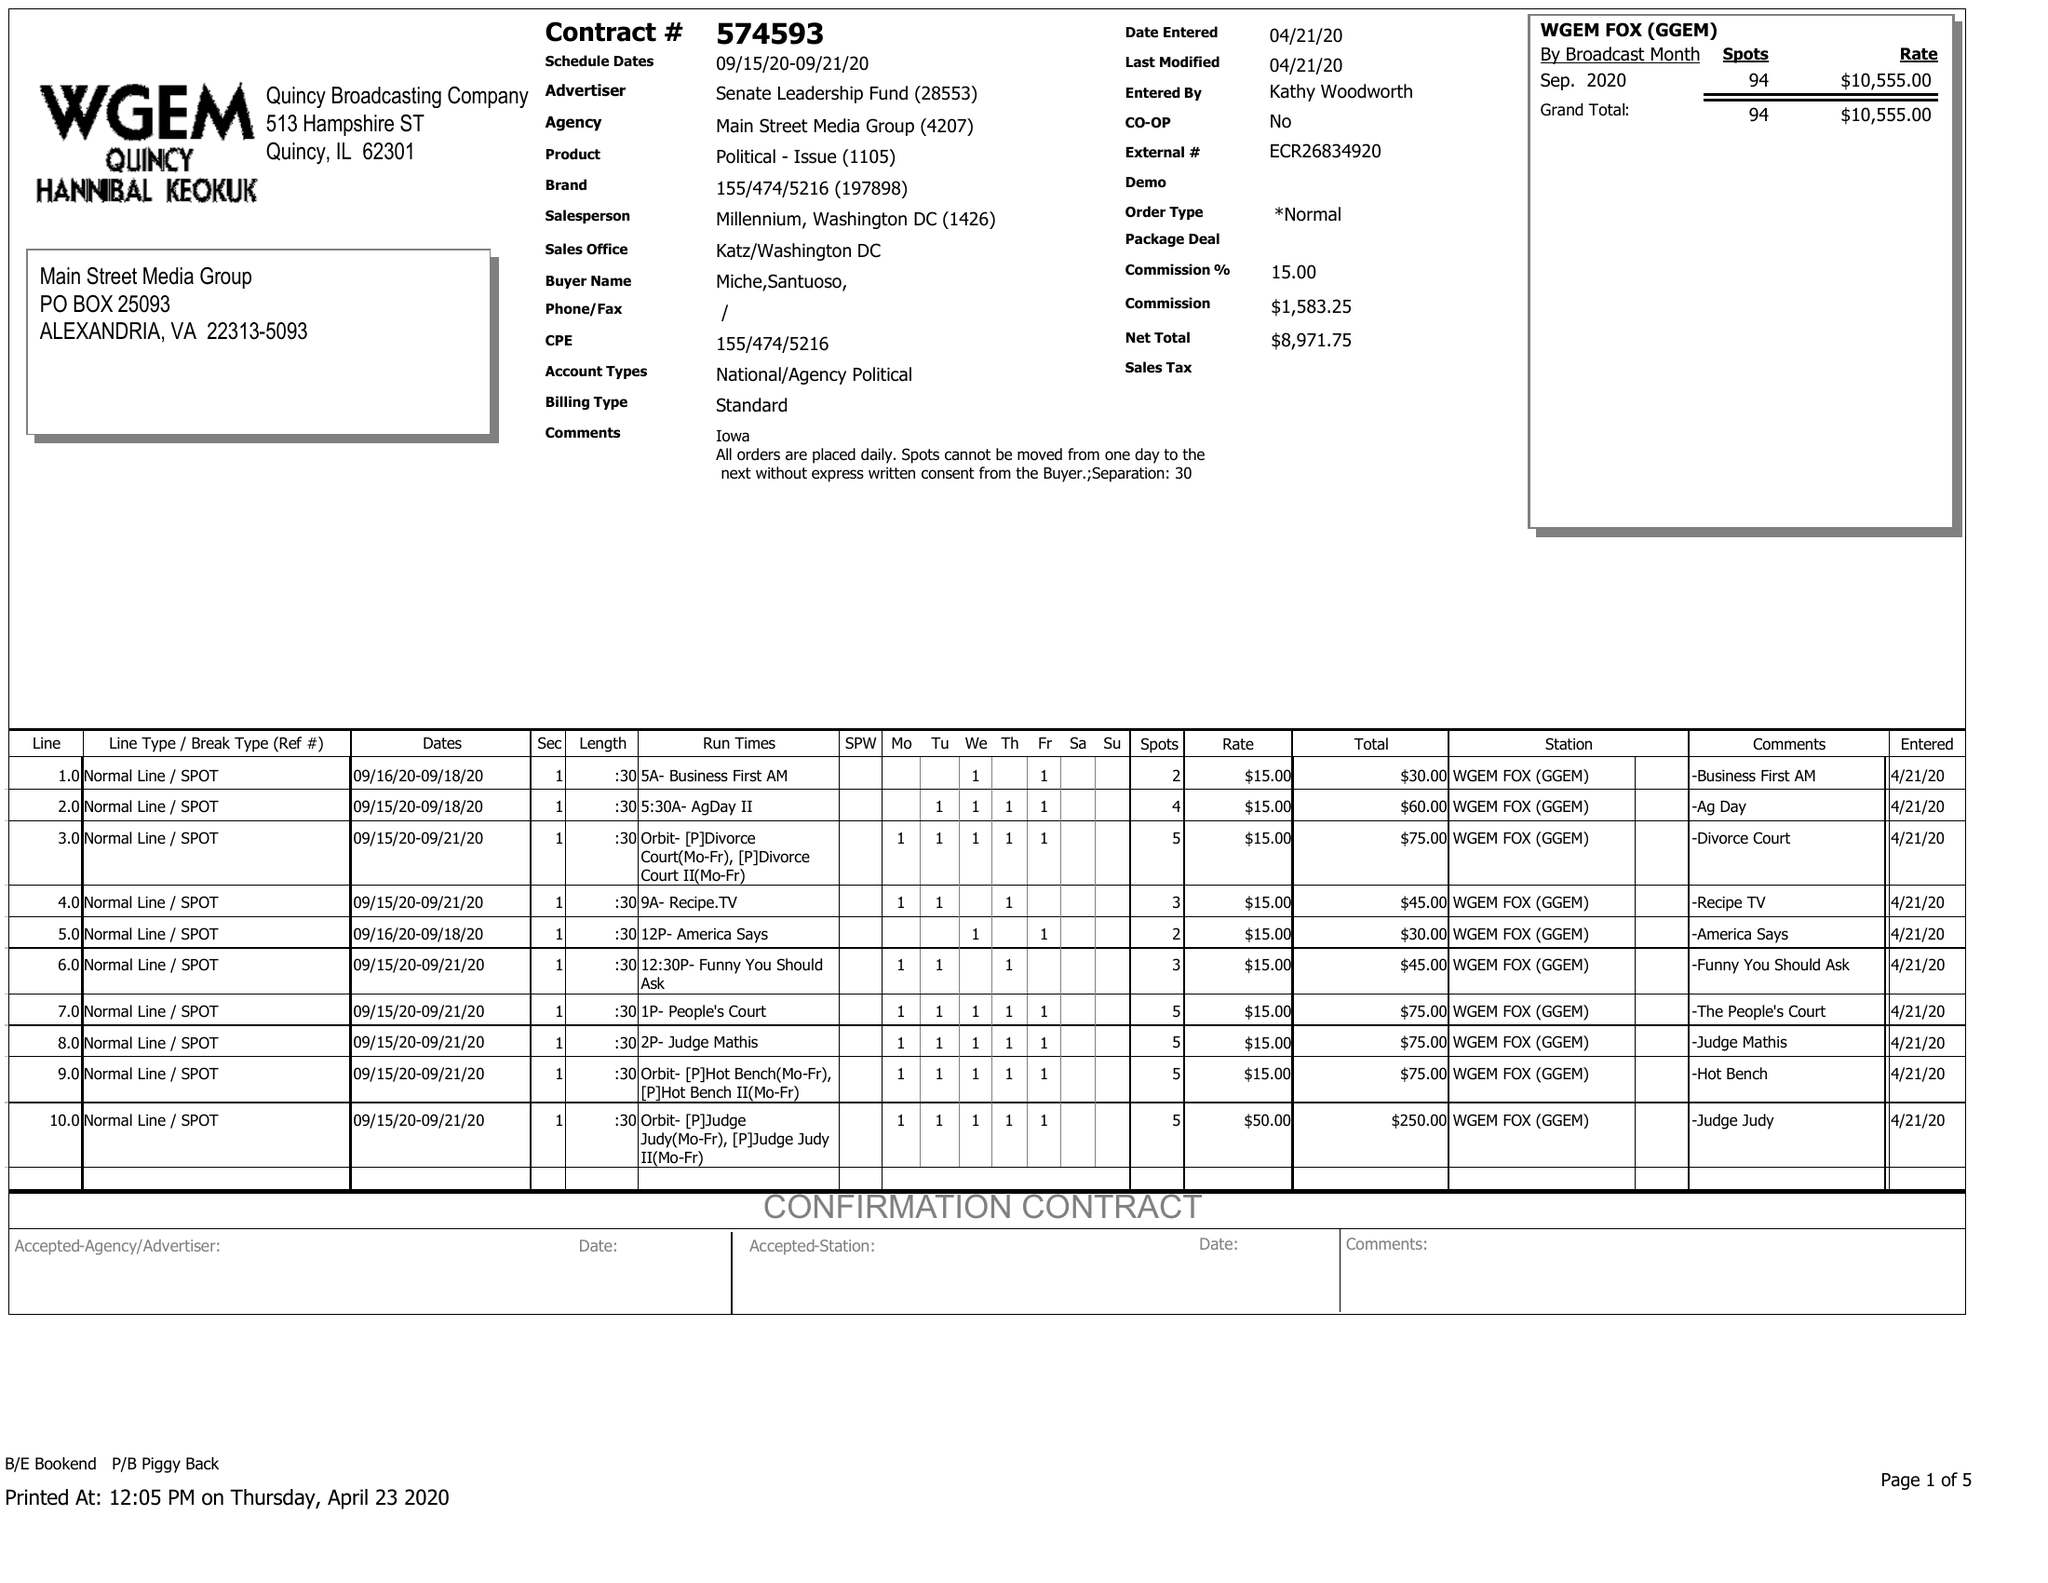What is the value for the contract_num?
Answer the question using a single word or phrase. 574593 